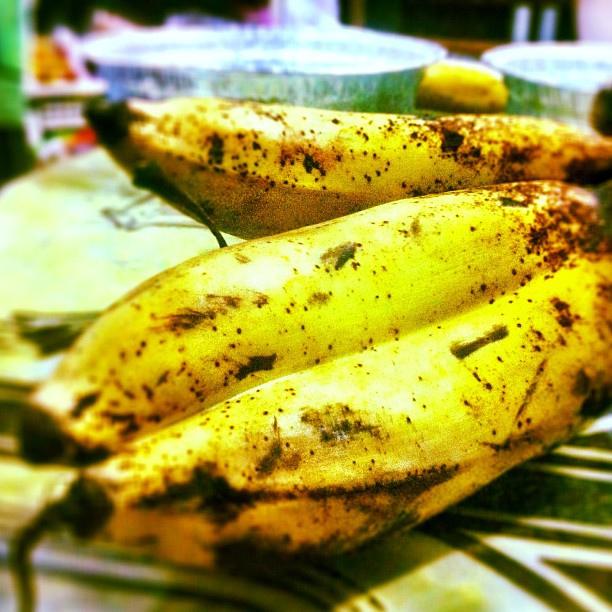What color is this food?
Quick response, please. Yellow. Are these bananas good for baking?
Quick response, please. Yes. What fruit is pictured?
Write a very short answer. Banana. 